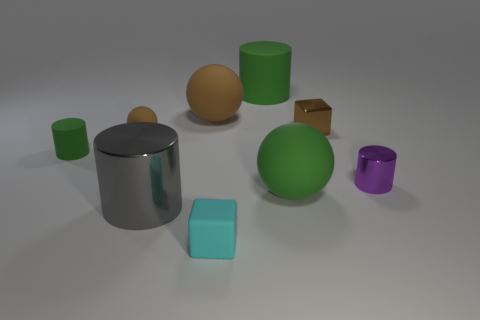What size is the other cylinder that is the same material as the large gray cylinder?
Your answer should be compact. Small. The tiny cylinder in front of the green object on the left side of the big gray cylinder is what color?
Provide a short and direct response. Purple. Does the purple shiny thing have the same shape as the small metal thing that is on the left side of the purple shiny cylinder?
Offer a very short reply. No. What number of matte balls have the same size as the rubber block?
Keep it short and to the point. 1. What material is the gray thing that is the same shape as the purple shiny object?
Provide a succinct answer. Metal. Does the small metallic object on the left side of the purple shiny cylinder have the same color as the small block in front of the large metal thing?
Ensure brevity in your answer.  No. There is a large green object in front of the large rubber cylinder; what shape is it?
Make the answer very short. Sphere. What is the color of the small matte block?
Make the answer very short. Cyan. There is a small green object that is made of the same material as the big brown object; what shape is it?
Offer a very short reply. Cylinder. Do the metal thing that is on the left side of the cyan rubber thing and the small green thing have the same size?
Your answer should be compact. No. 